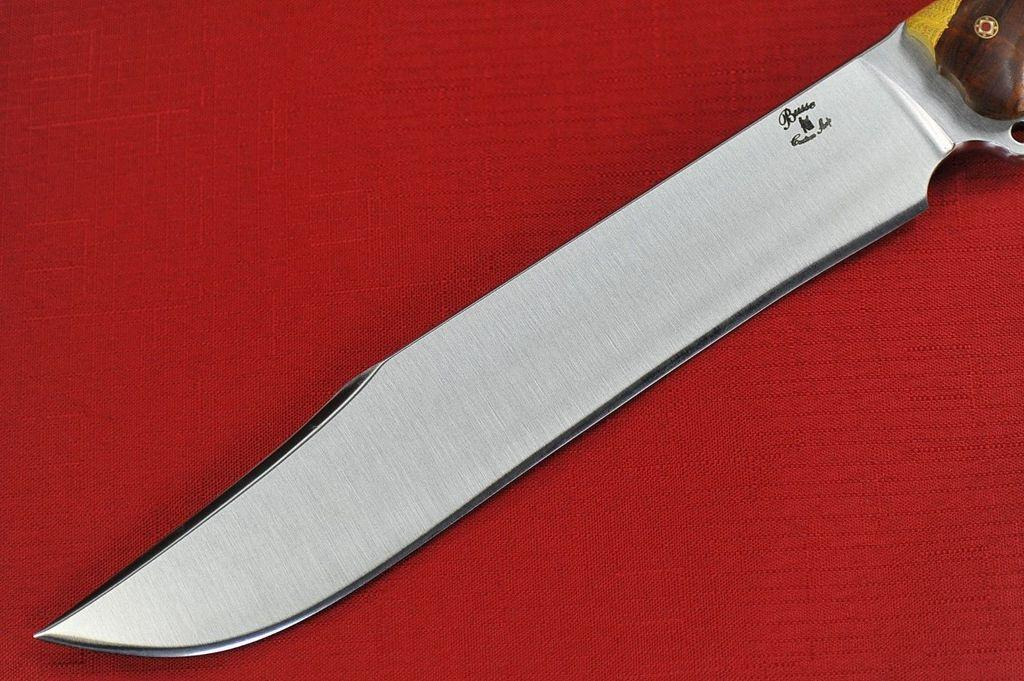What object is the main focus of the image? There is a dagger in the image. What is the dagger placed on? The dagger is on a red color cloth. What type of lead can be seen attached to the dagger in the image? There is no lead attached to the dagger in the image. How does the tongue interact with the dagger in the image? There is no tongue present in the image, so it cannot interact with the dagger. 